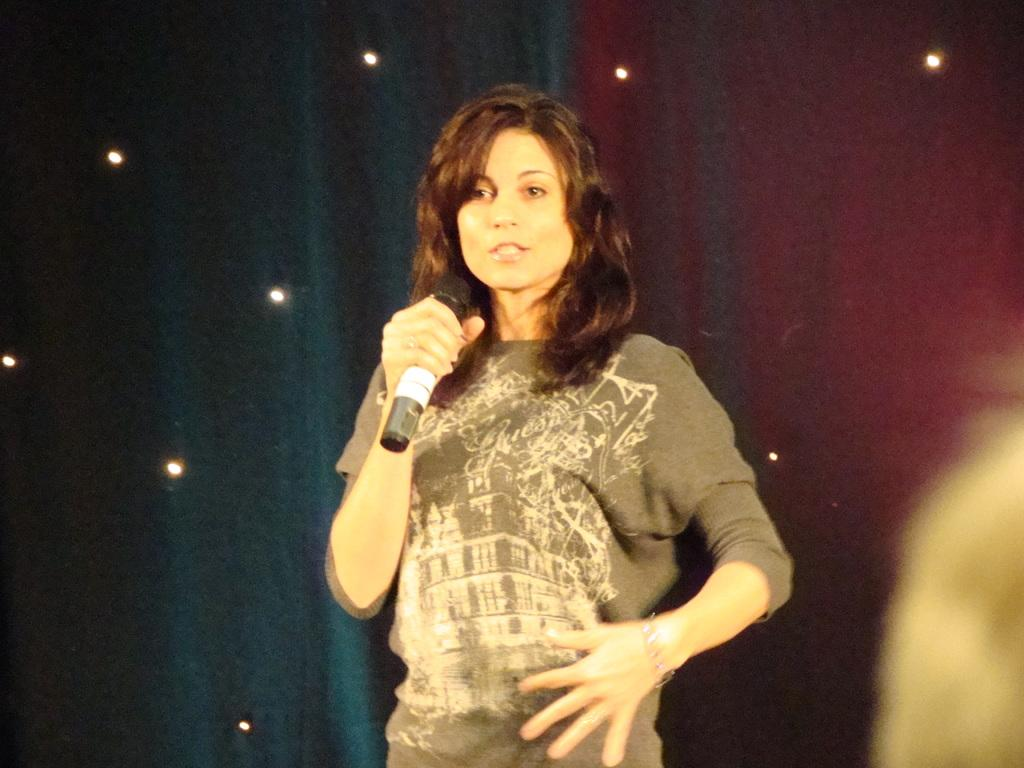What is the main subject of the image? There is a woman in the image. What is the woman doing in the image? The woman is standing and talking in the image. What is the woman holding in the image? The woman is holding a microphone in the image. What is the woman wearing in the image? The woman is wearing a T-shirt in the image. How would you describe the background of the image? The background of the image is colorful and has small lights. What type of tail can be seen on the woman in the image? There is no tail visible on the woman in the image. What kind of oatmeal is being served in the background of the image? There is no oatmeal present in the image. 